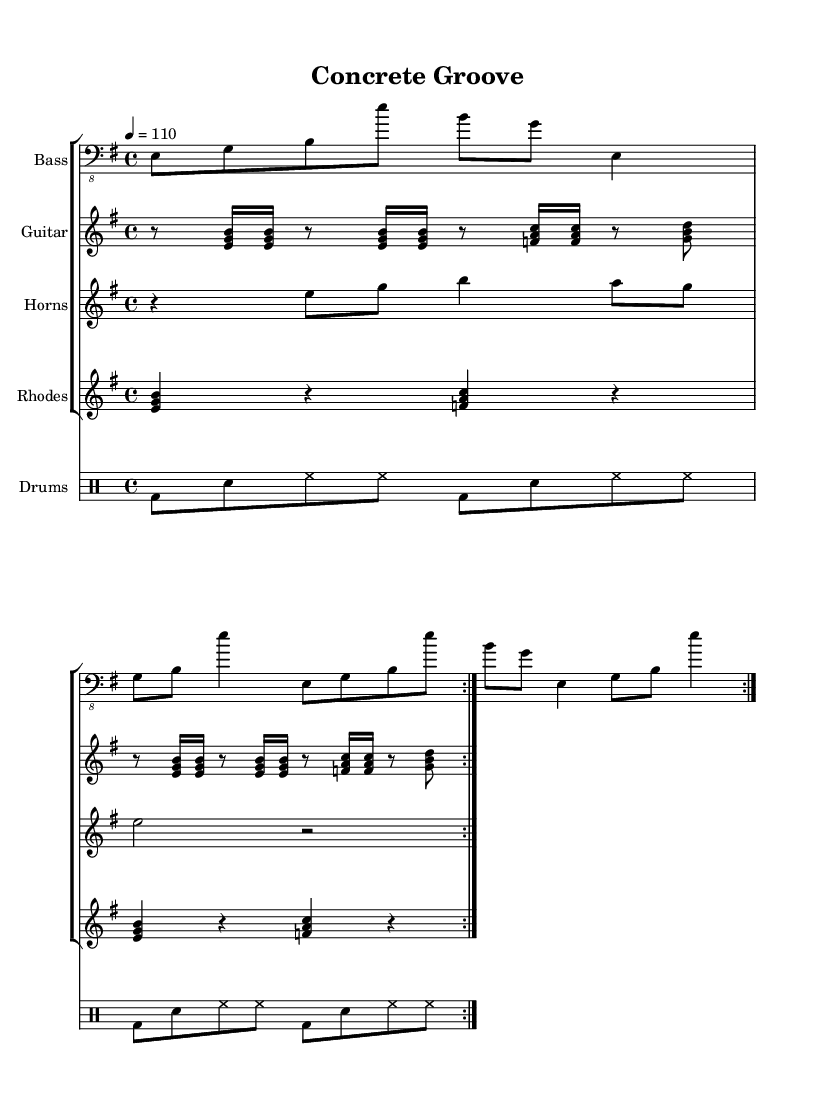What is the key signature of this music? The key signature is indicated by the sharp and flat symbols placed after the clef. In this case, there are no sharps or flats shown, signifying that the key is E minor.
Answer: E minor What is the time signature of this piece? The time signature is located on the staff following the key signature, expressed by two numbers stacked vertically. Here, the time signature is 4 over 4, meaning there are four beats in a measure, and the quarter note gets one beat.
Answer: 4/4 What is the tempo marking of the piece? The tempo marking is found above the staff, indicating the speed of the piece. In this case, it states "4 = 110," meaning the piece should be played at a tempo of 110 beats per minute.
Answer: 110 How many times should the bass line repeat? The repeat sign is visible in the bass line section, denoted by the volta markings. It indicates that the bass line should be played twice through the specified measures.
Answer: 2 What instruments are featured in this arrangement? The different staves indicate various instruments, specifically: Bass, Guitar, Horns, and Rhodes, plus a separate staff for Drums. All of these sections contribute to the overall funk groove.
Answer: Bass, Guitar, Horns, Rhodes, Drums What type of rhythmic feel does the drum pattern primarily exhibit? The drum pattern features a steady driving beat characterized by a consistent bass drum hit, snare drum, and hi-hats, which is typical in funk music for providing a strong, danceable rhythm.
Answer: Funk groove What is the highest pitch used in the horn section? The notes in the horn section can be analyzed by finding the highest note in the written sequence. Here, the highest note present is B4, which is the highest pitch used in this part.
Answer: B4 